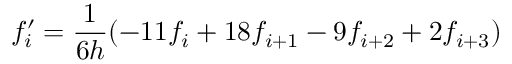<formula> <loc_0><loc_0><loc_500><loc_500>f _ { i } ^ { \prime } = \frac { 1 } { 6 h } ( - 1 1 f _ { i } + 1 8 f _ { i + 1 } - 9 f _ { i + 2 } + 2 f _ { i + 3 } )</formula> 